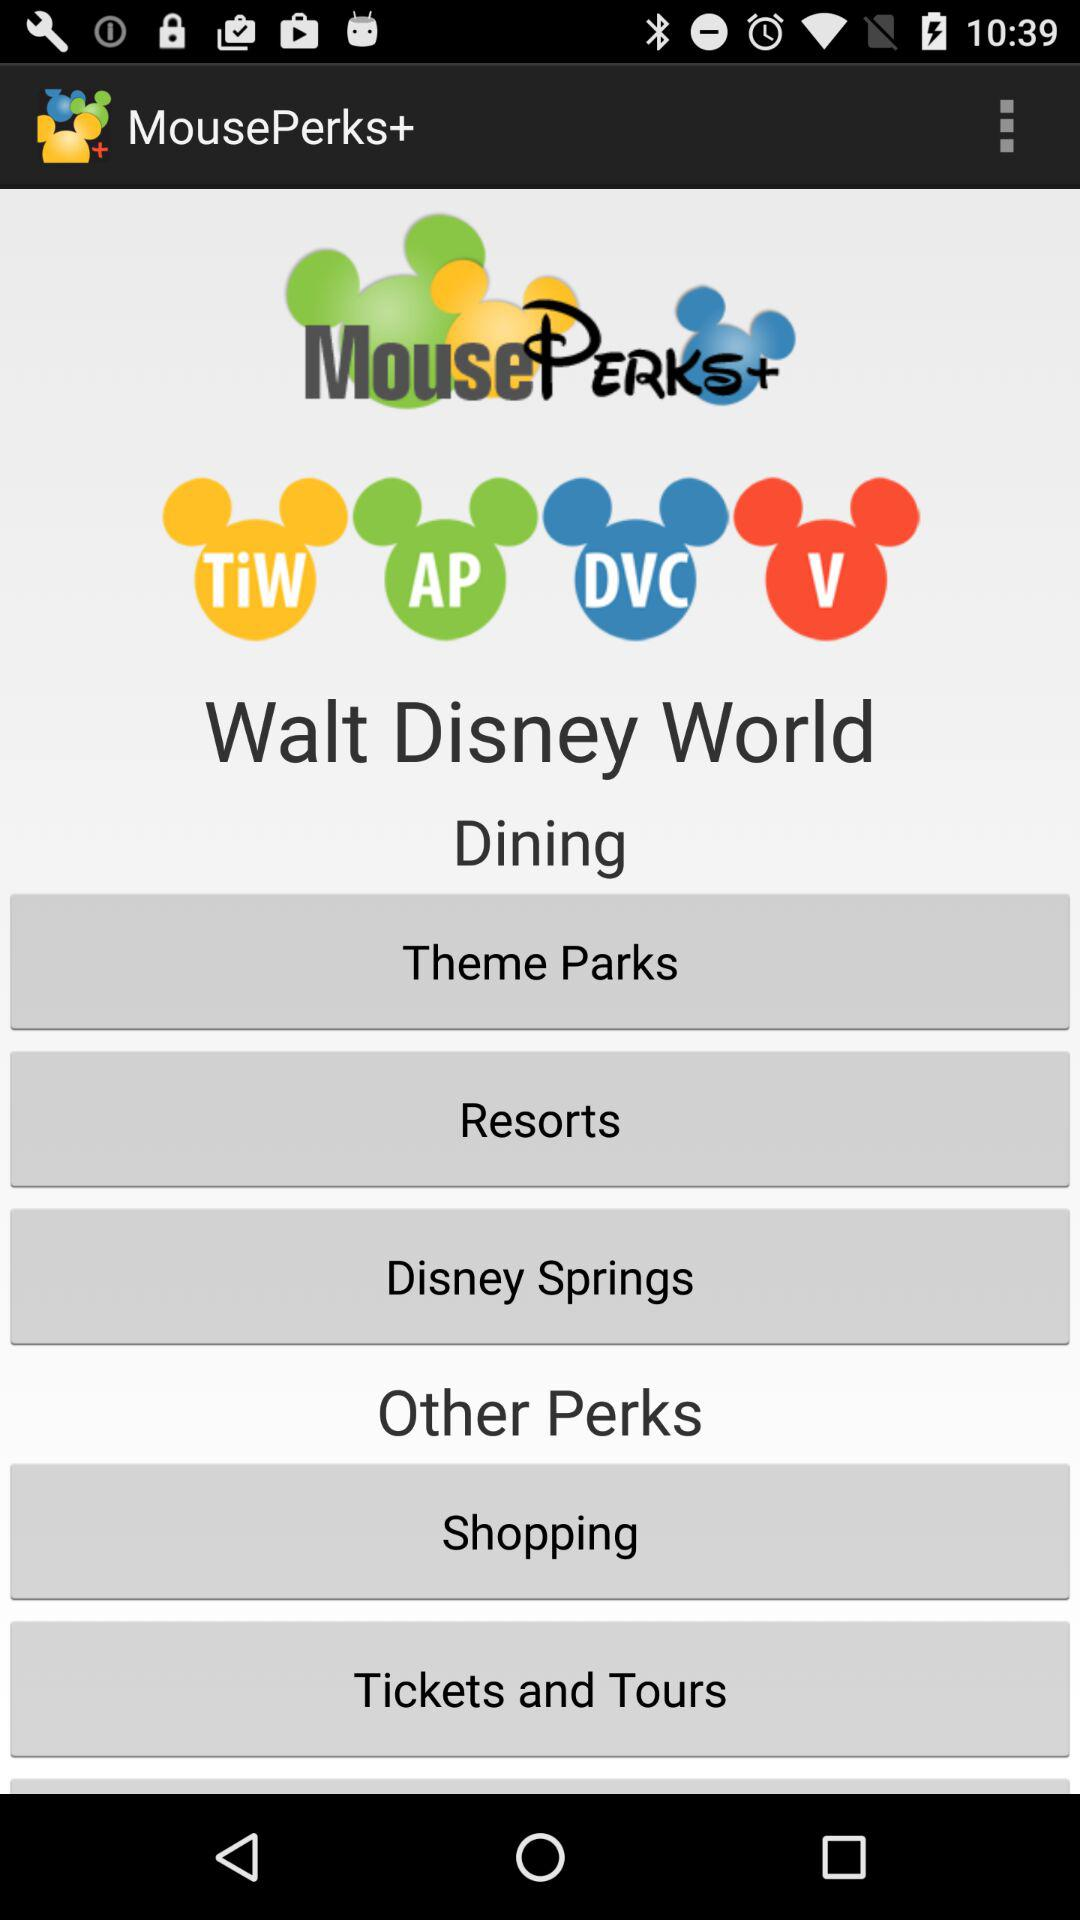How much are the tickets?
When the provided information is insufficient, respond with <no answer>. <no answer> 